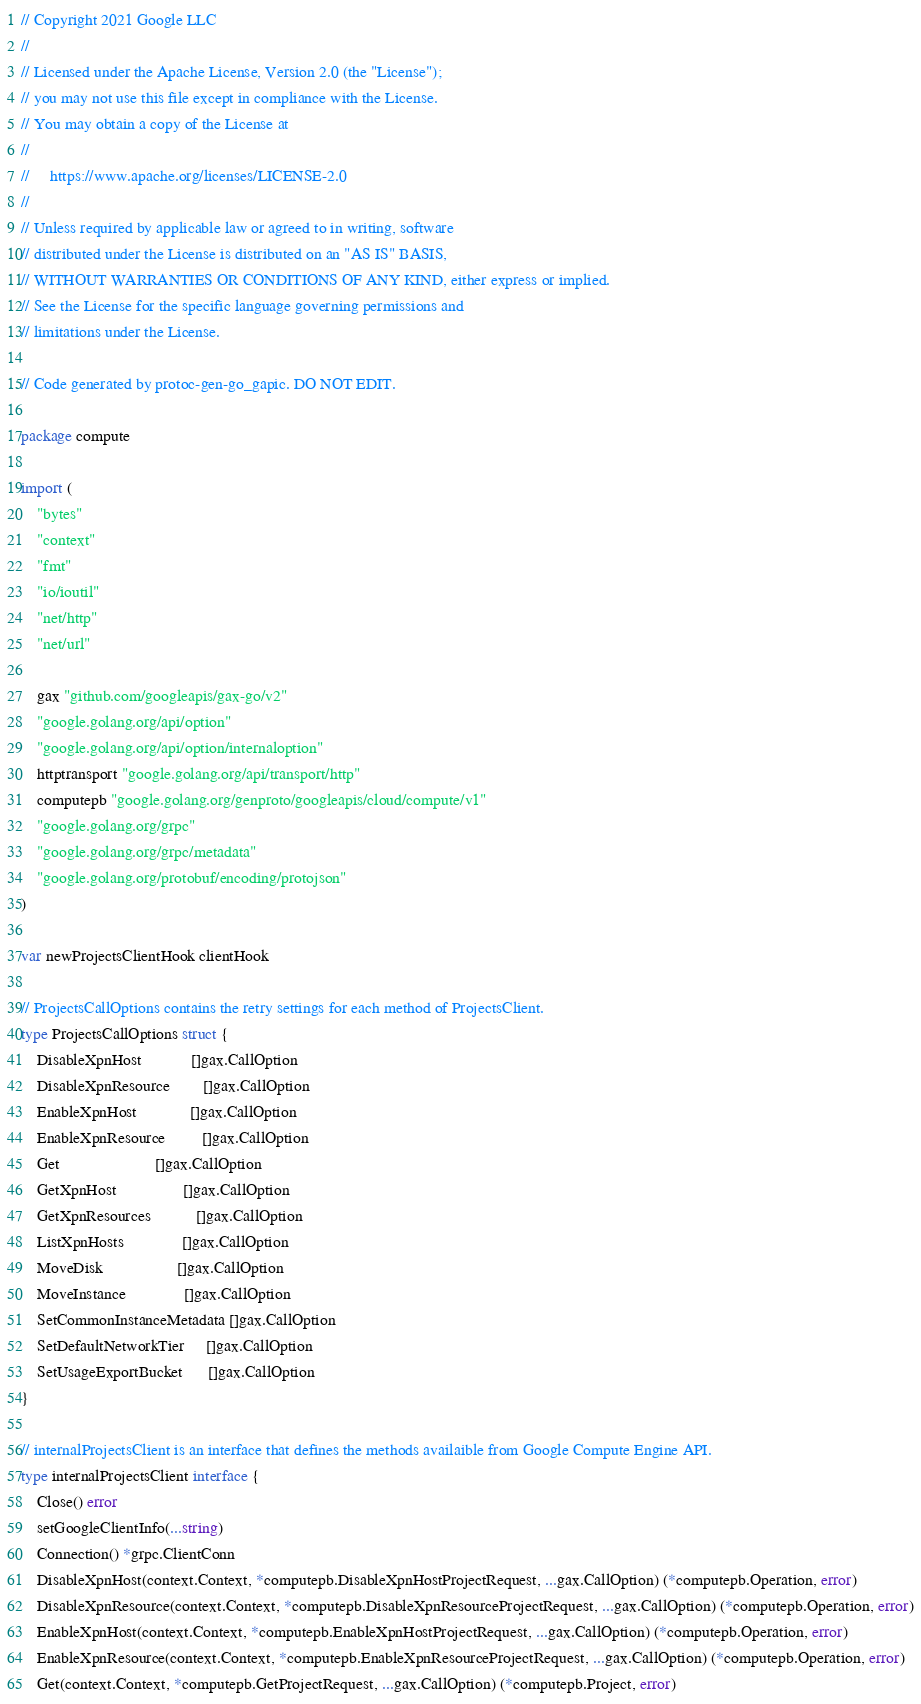<code> <loc_0><loc_0><loc_500><loc_500><_Go_>// Copyright 2021 Google LLC
//
// Licensed under the Apache License, Version 2.0 (the "License");
// you may not use this file except in compliance with the License.
// You may obtain a copy of the License at
//
//     https://www.apache.org/licenses/LICENSE-2.0
//
// Unless required by applicable law or agreed to in writing, software
// distributed under the License is distributed on an "AS IS" BASIS,
// WITHOUT WARRANTIES OR CONDITIONS OF ANY KIND, either express or implied.
// See the License for the specific language governing permissions and
// limitations under the License.

// Code generated by protoc-gen-go_gapic. DO NOT EDIT.

package compute

import (
	"bytes"
	"context"
	"fmt"
	"io/ioutil"
	"net/http"
	"net/url"

	gax "github.com/googleapis/gax-go/v2"
	"google.golang.org/api/option"
	"google.golang.org/api/option/internaloption"
	httptransport "google.golang.org/api/transport/http"
	computepb "google.golang.org/genproto/googleapis/cloud/compute/v1"
	"google.golang.org/grpc"
	"google.golang.org/grpc/metadata"
	"google.golang.org/protobuf/encoding/protojson"
)

var newProjectsClientHook clientHook

// ProjectsCallOptions contains the retry settings for each method of ProjectsClient.
type ProjectsCallOptions struct {
	DisableXpnHost            []gax.CallOption
	DisableXpnResource        []gax.CallOption
	EnableXpnHost             []gax.CallOption
	EnableXpnResource         []gax.CallOption
	Get                       []gax.CallOption
	GetXpnHost                []gax.CallOption
	GetXpnResources           []gax.CallOption
	ListXpnHosts              []gax.CallOption
	MoveDisk                  []gax.CallOption
	MoveInstance              []gax.CallOption
	SetCommonInstanceMetadata []gax.CallOption
	SetDefaultNetworkTier     []gax.CallOption
	SetUsageExportBucket      []gax.CallOption
}

// internalProjectsClient is an interface that defines the methods availaible from Google Compute Engine API.
type internalProjectsClient interface {
	Close() error
	setGoogleClientInfo(...string)
	Connection() *grpc.ClientConn
	DisableXpnHost(context.Context, *computepb.DisableXpnHostProjectRequest, ...gax.CallOption) (*computepb.Operation, error)
	DisableXpnResource(context.Context, *computepb.DisableXpnResourceProjectRequest, ...gax.CallOption) (*computepb.Operation, error)
	EnableXpnHost(context.Context, *computepb.EnableXpnHostProjectRequest, ...gax.CallOption) (*computepb.Operation, error)
	EnableXpnResource(context.Context, *computepb.EnableXpnResourceProjectRequest, ...gax.CallOption) (*computepb.Operation, error)
	Get(context.Context, *computepb.GetProjectRequest, ...gax.CallOption) (*computepb.Project, error)</code> 